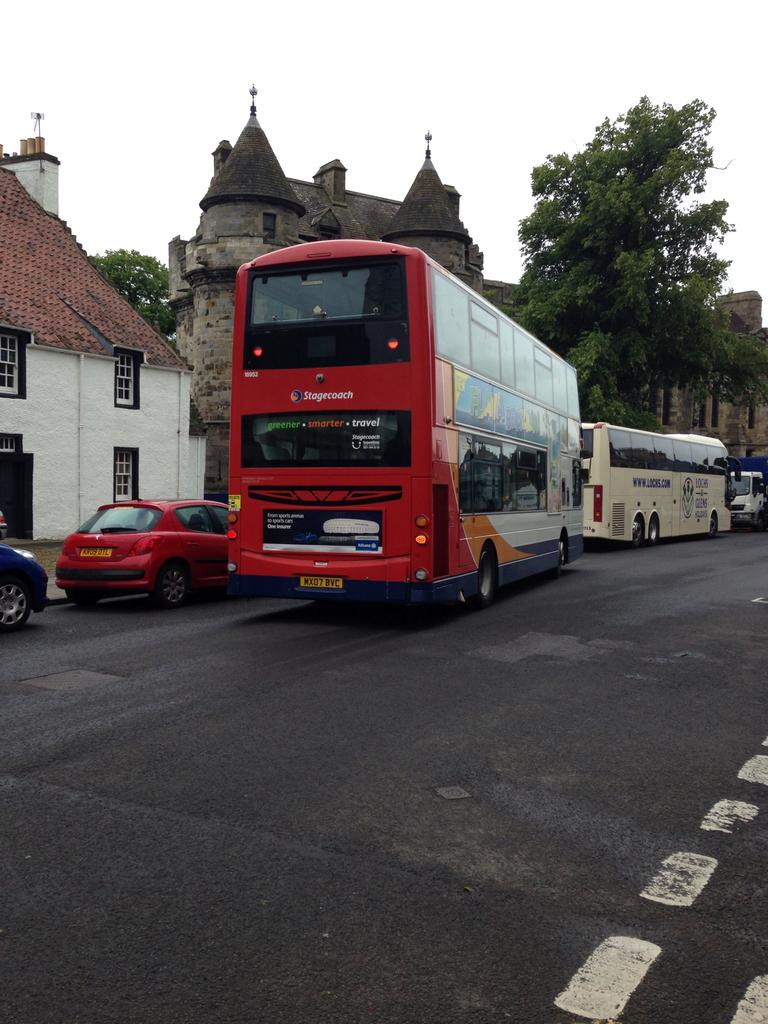<image>
Provide a brief description of the given image. A double decker Stagecoach tourist bus in an old city. 